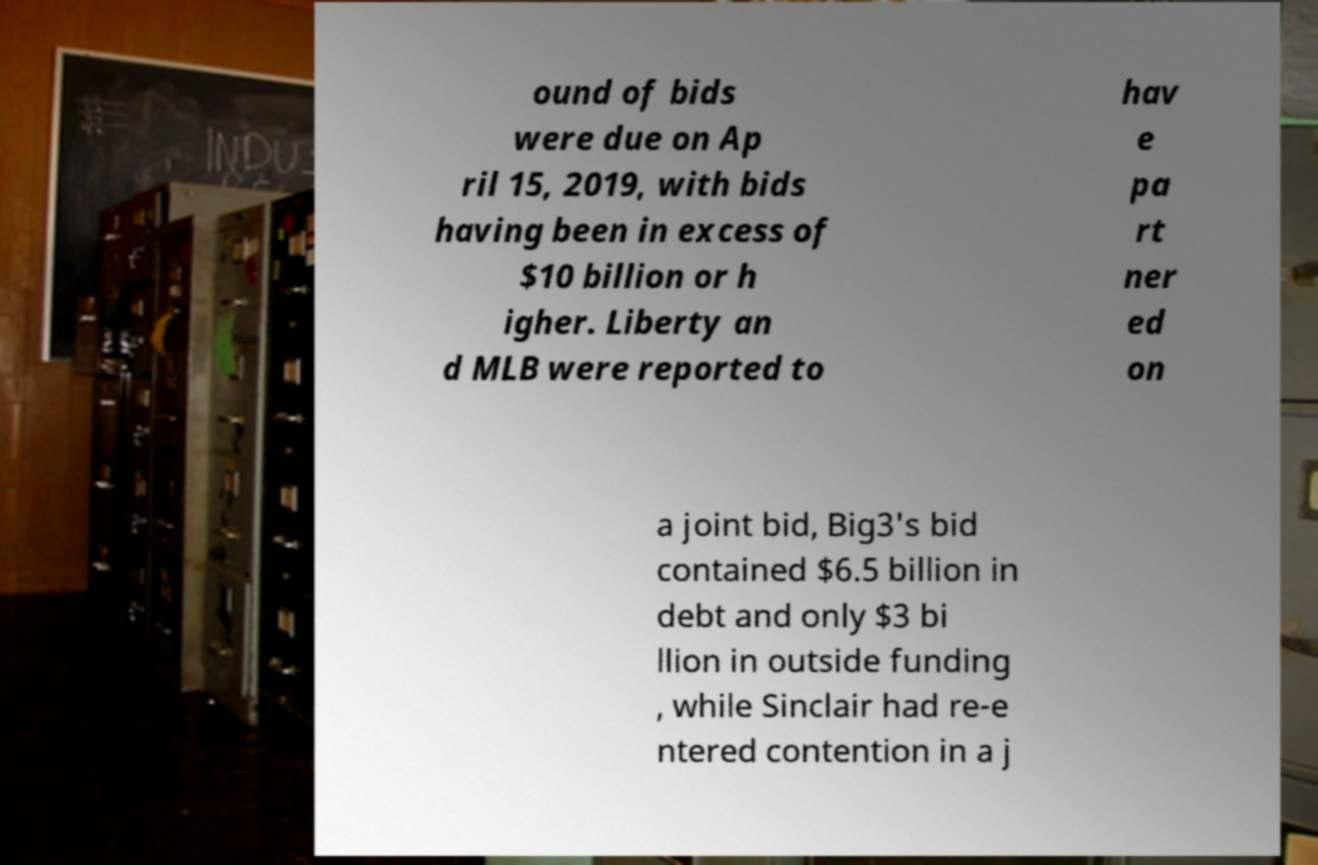Can you read and provide the text displayed in the image?This photo seems to have some interesting text. Can you extract and type it out for me? ound of bids were due on Ap ril 15, 2019, with bids having been in excess of $10 billion or h igher. Liberty an d MLB were reported to hav e pa rt ner ed on a joint bid, Big3's bid contained $6.5 billion in debt and only $3 bi llion in outside funding , while Sinclair had re-e ntered contention in a j 